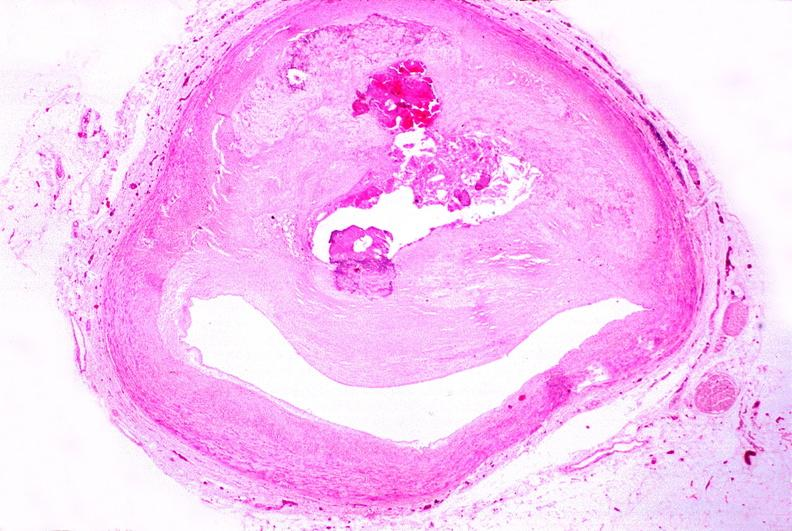what is present?
Answer the question using a single word or phrase. Vasculature 